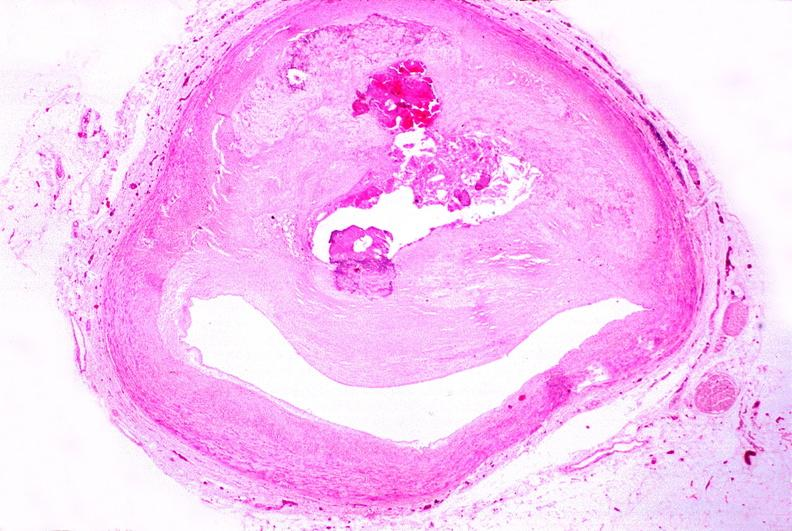what is present?
Answer the question using a single word or phrase. Vasculature 